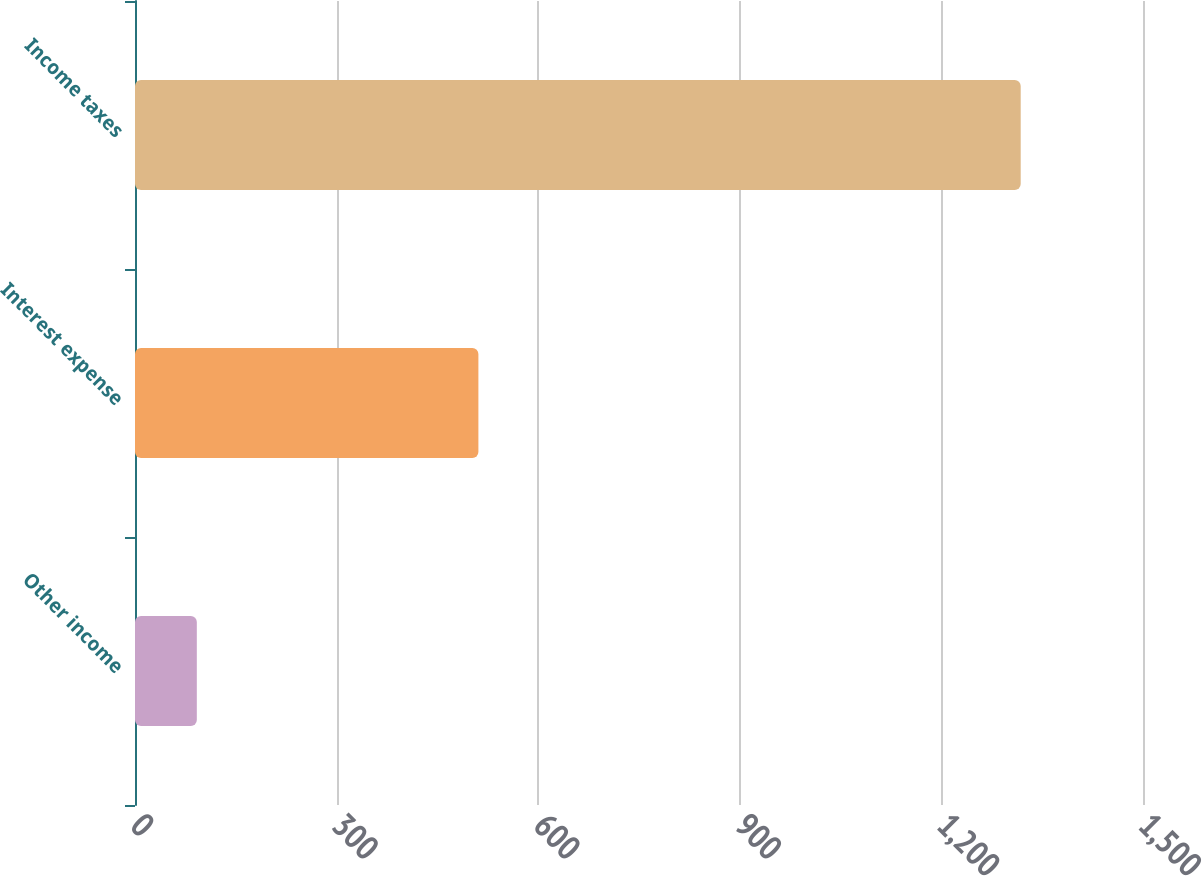<chart> <loc_0><loc_0><loc_500><loc_500><bar_chart><fcel>Other income<fcel>Interest expense<fcel>Income taxes<nl><fcel>92<fcel>511<fcel>1318<nl></chart> 